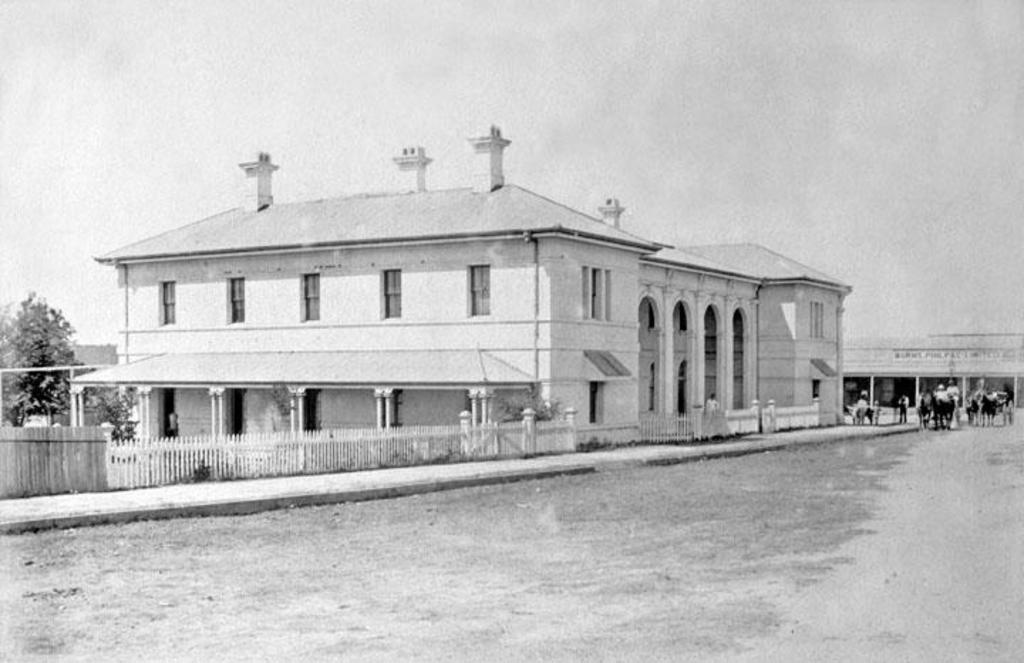Describe this image in one or two sentences. It is a black and white image. In this image we can see the buildings, trees, fence and also the path. We can also see the people and also the horse drawn vehicles. Sky is also visible in this image. 